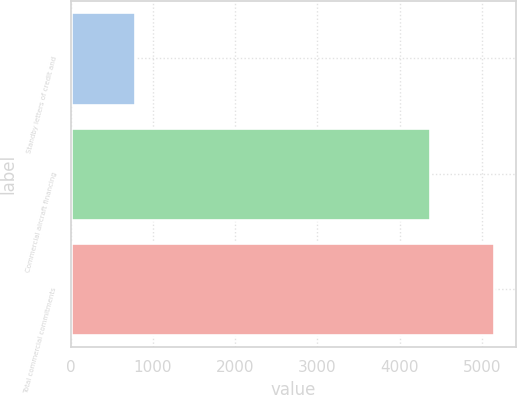<chart> <loc_0><loc_0><loc_500><loc_500><bar_chart><fcel>Standby letters of credit and<fcel>Commercial aircraft financing<fcel>Total commercial commitments<nl><fcel>782<fcel>4372<fcel>5154<nl></chart> 